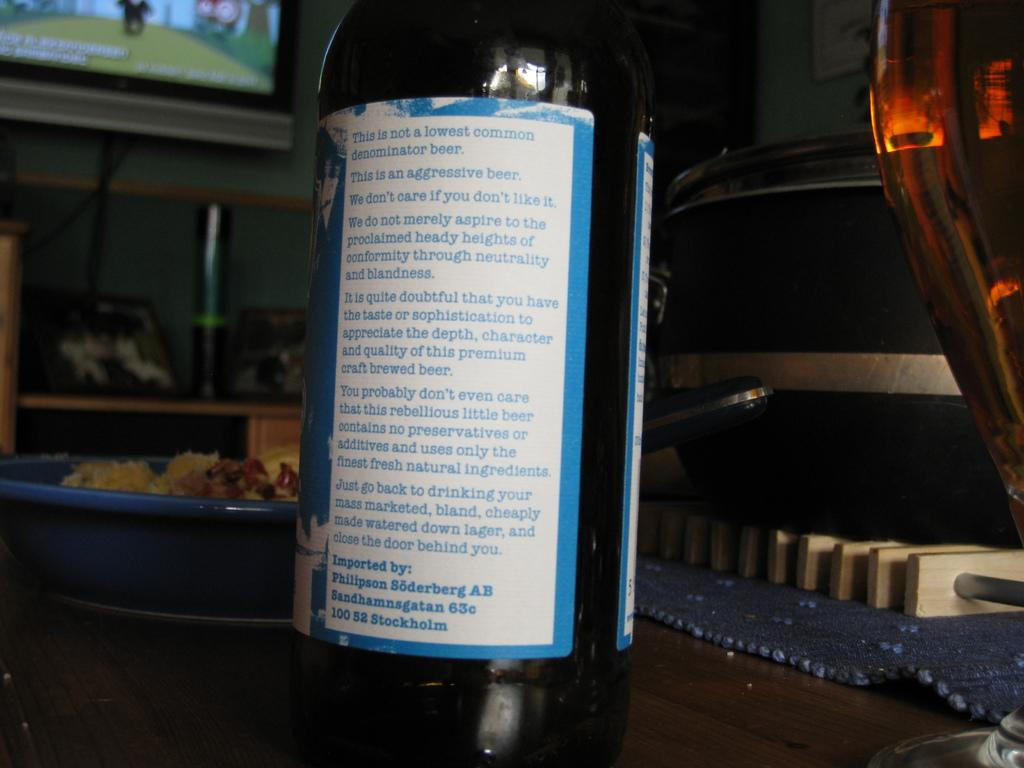<image>
Present a compact description of the photo's key features. The back ingredients of a bottle from Stockholm 